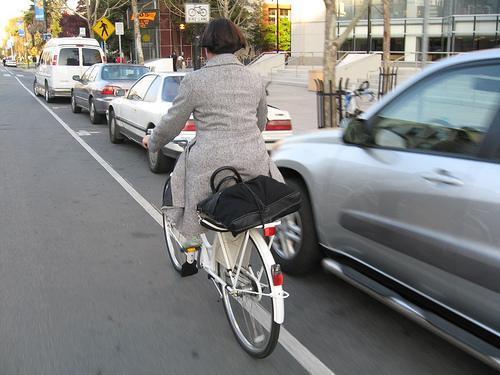How many bicycles are there?
Give a very brief answer. 1. 